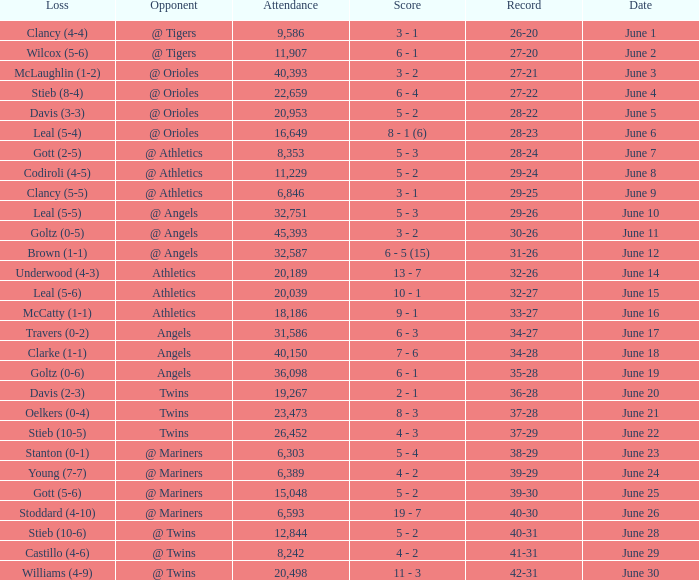What was the record for the date of June 14? 32-26. I'm looking to parse the entire table for insights. Could you assist me with that? {'header': ['Loss', 'Opponent', 'Attendance', 'Score', 'Record', 'Date'], 'rows': [['Clancy (4-4)', '@ Tigers', '9,586', '3 - 1', '26-20', 'June 1'], ['Wilcox (5-6)', '@ Tigers', '11,907', '6 - 1', '27-20', 'June 2'], ['McLaughlin (1-2)', '@ Orioles', '40,393', '3 - 2', '27-21', 'June 3'], ['Stieb (8-4)', '@ Orioles', '22,659', '6 - 4', '27-22', 'June 4'], ['Davis (3-3)', '@ Orioles', '20,953', '5 - 2', '28-22', 'June 5'], ['Leal (5-4)', '@ Orioles', '16,649', '8 - 1 (6)', '28-23', 'June 6'], ['Gott (2-5)', '@ Athletics', '8,353', '5 - 3', '28-24', 'June 7'], ['Codiroli (4-5)', '@ Athletics', '11,229', '5 - 2', '29-24', 'June 8'], ['Clancy (5-5)', '@ Athletics', '6,846', '3 - 1', '29-25', 'June 9'], ['Leal (5-5)', '@ Angels', '32,751', '5 - 3', '29-26', 'June 10'], ['Goltz (0-5)', '@ Angels', '45,393', '3 - 2', '30-26', 'June 11'], ['Brown (1-1)', '@ Angels', '32,587', '6 - 5 (15)', '31-26', 'June 12'], ['Underwood (4-3)', 'Athletics', '20,189', '13 - 7', '32-26', 'June 14'], ['Leal (5-6)', 'Athletics', '20,039', '10 - 1', '32-27', 'June 15'], ['McCatty (1-1)', 'Athletics', '18,186', '9 - 1', '33-27', 'June 16'], ['Travers (0-2)', 'Angels', '31,586', '6 - 3', '34-27', 'June 17'], ['Clarke (1-1)', 'Angels', '40,150', '7 - 6', '34-28', 'June 18'], ['Goltz (0-6)', 'Angels', '36,098', '6 - 1', '35-28', 'June 19'], ['Davis (2-3)', 'Twins', '19,267', '2 - 1', '36-28', 'June 20'], ['Oelkers (0-4)', 'Twins', '23,473', '8 - 3', '37-28', 'June 21'], ['Stieb (10-5)', 'Twins', '26,452', '4 - 3', '37-29', 'June 22'], ['Stanton (0-1)', '@ Mariners', '6,303', '5 - 4', '38-29', 'June 23'], ['Young (7-7)', '@ Mariners', '6,389', '4 - 2', '39-29', 'June 24'], ['Gott (5-6)', '@ Mariners', '15,048', '5 - 2', '39-30', 'June 25'], ['Stoddard (4-10)', '@ Mariners', '6,593', '19 - 7', '40-30', 'June 26'], ['Stieb (10-6)', '@ Twins', '12,844', '5 - 2', '40-31', 'June 28'], ['Castillo (4-6)', '@ Twins', '8,242', '4 - 2', '41-31', 'June 29'], ['Williams (4-9)', '@ Twins', '20,498', '11 - 3', '42-31', 'June 30']]} 